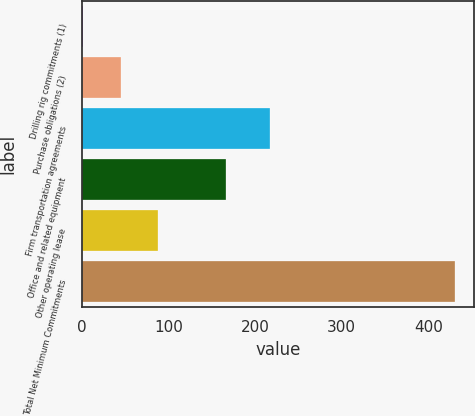Convert chart. <chart><loc_0><loc_0><loc_500><loc_500><bar_chart><fcel>Drilling rig commitments (1)<fcel>Purchase obligations (2)<fcel>Firm transportation agreements<fcel>Office and related equipment<fcel>Other operating lease<fcel>Total Net Minimum Commitments<nl><fcel>2<fcel>44.9<fcel>217<fcel>166<fcel>87.8<fcel>431<nl></chart> 